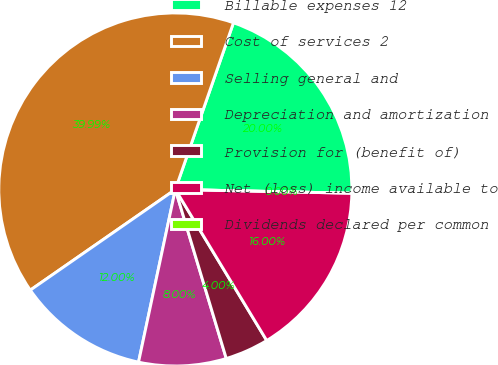Convert chart. <chart><loc_0><loc_0><loc_500><loc_500><pie_chart><fcel>Billable expenses 12<fcel>Cost of services 2<fcel>Selling general and<fcel>Depreciation and amortization<fcel>Provision for (benefit of)<fcel>Net (loss) income available to<fcel>Dividends declared per common<nl><fcel>20.0%<fcel>39.99%<fcel>12.0%<fcel>8.0%<fcel>4.0%<fcel>16.0%<fcel>0.0%<nl></chart> 